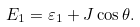<formula> <loc_0><loc_0><loc_500><loc_500>E _ { 1 } = { \varepsilon } _ { 1 } + J \cos \theta .</formula> 